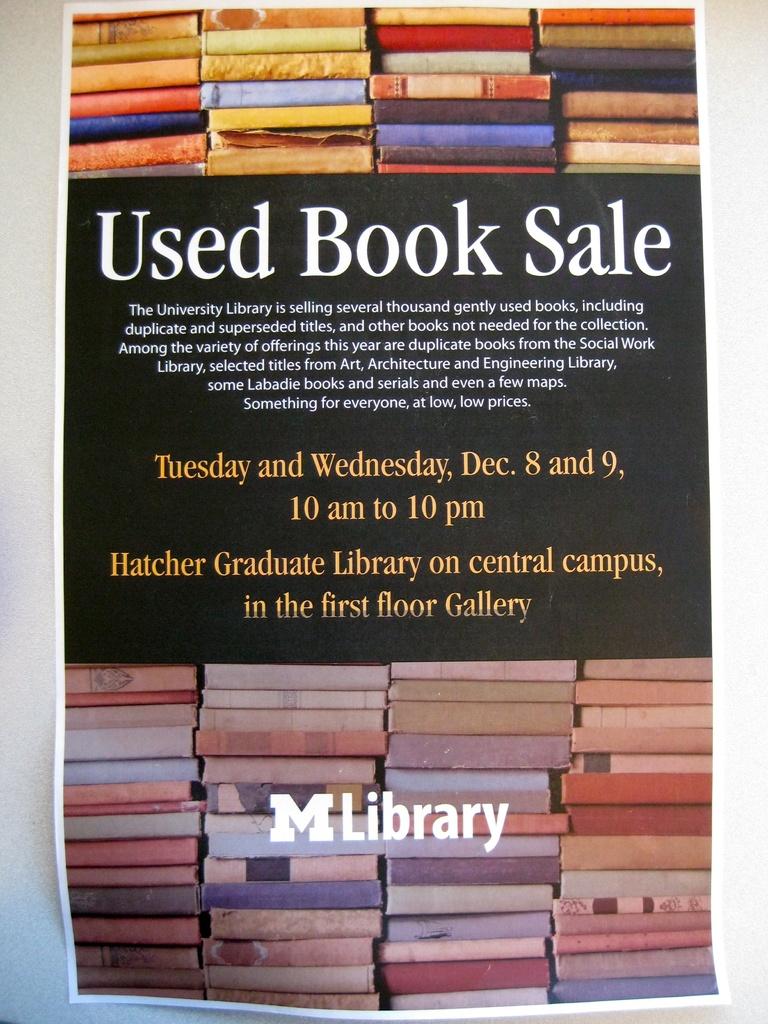Where is the sale located?
Your response must be concise. Hatcher graduate library. Is this about a used book sale ?
Give a very brief answer. Yes. 